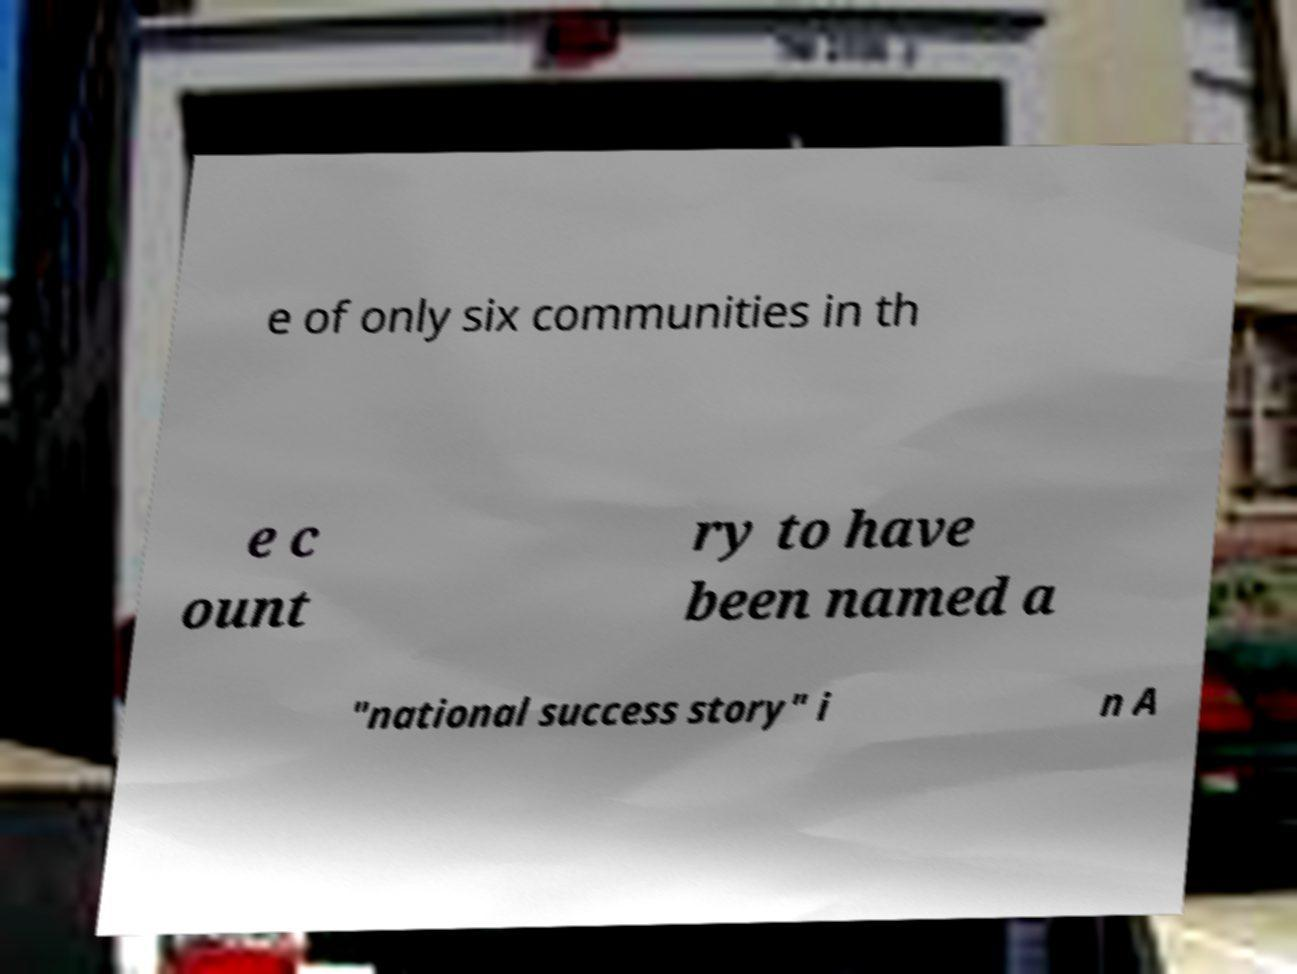Could you assist in decoding the text presented in this image and type it out clearly? e of only six communities in th e c ount ry to have been named a "national success story" i n A 